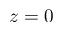Convert formula to latex. <formula><loc_0><loc_0><loc_500><loc_500>z = 0</formula> 